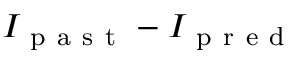Convert formula to latex. <formula><loc_0><loc_0><loc_500><loc_500>I _ { p a s t } - I _ { p r e d }</formula> 